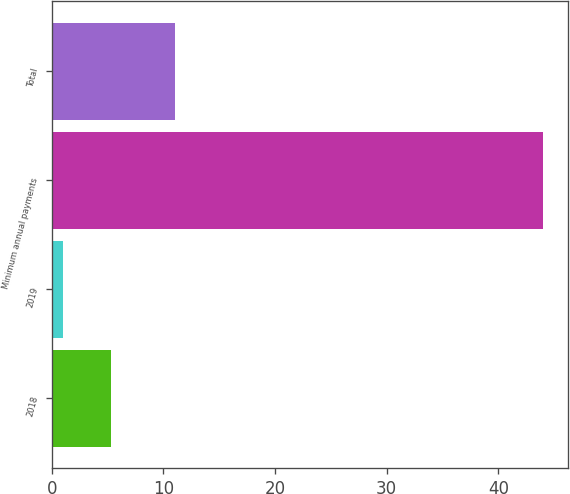Convert chart to OTSL. <chart><loc_0><loc_0><loc_500><loc_500><bar_chart><fcel>2018<fcel>2019<fcel>Minimum annual payments<fcel>Total<nl><fcel>5.3<fcel>1<fcel>44<fcel>11<nl></chart> 